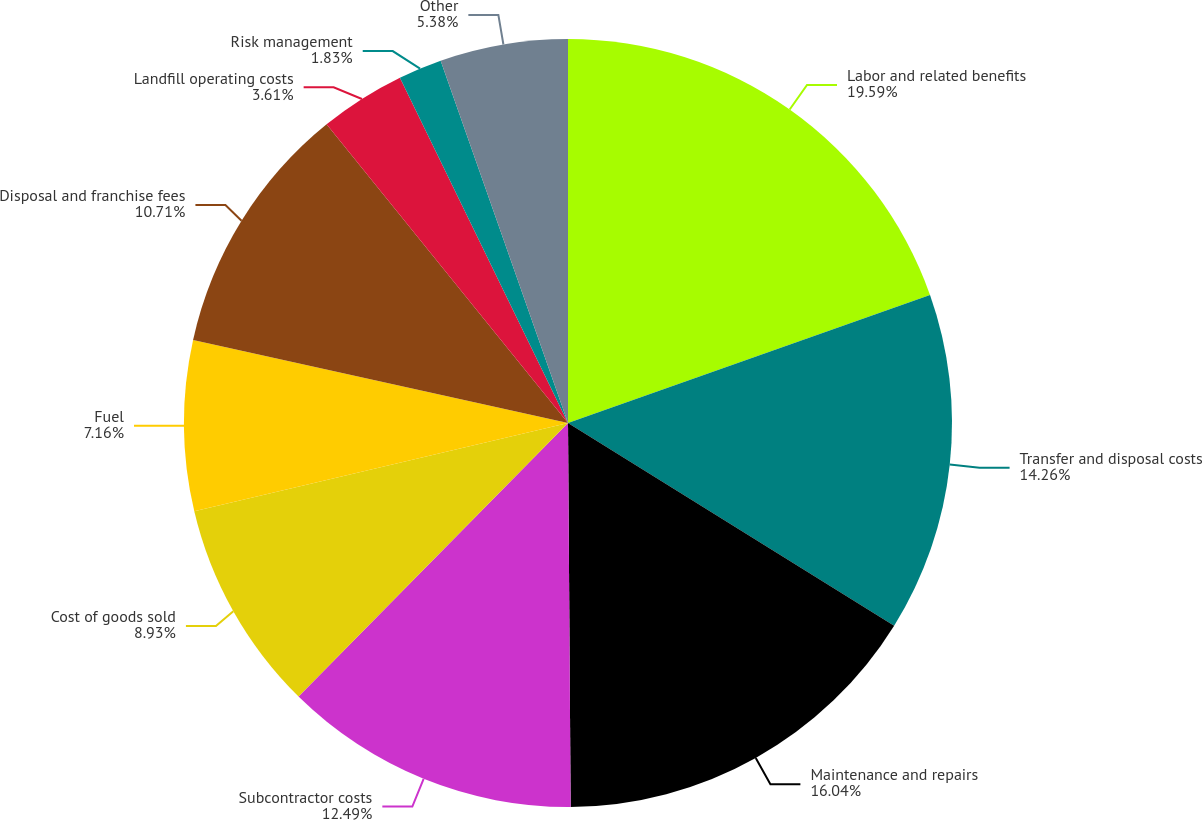Convert chart. <chart><loc_0><loc_0><loc_500><loc_500><pie_chart><fcel>Labor and related benefits<fcel>Transfer and disposal costs<fcel>Maintenance and repairs<fcel>Subcontractor costs<fcel>Cost of goods sold<fcel>Fuel<fcel>Disposal and franchise fees<fcel>Landfill operating costs<fcel>Risk management<fcel>Other<nl><fcel>19.59%<fcel>14.26%<fcel>16.04%<fcel>12.49%<fcel>8.93%<fcel>7.16%<fcel>10.71%<fcel>3.61%<fcel>1.83%<fcel>5.38%<nl></chart> 